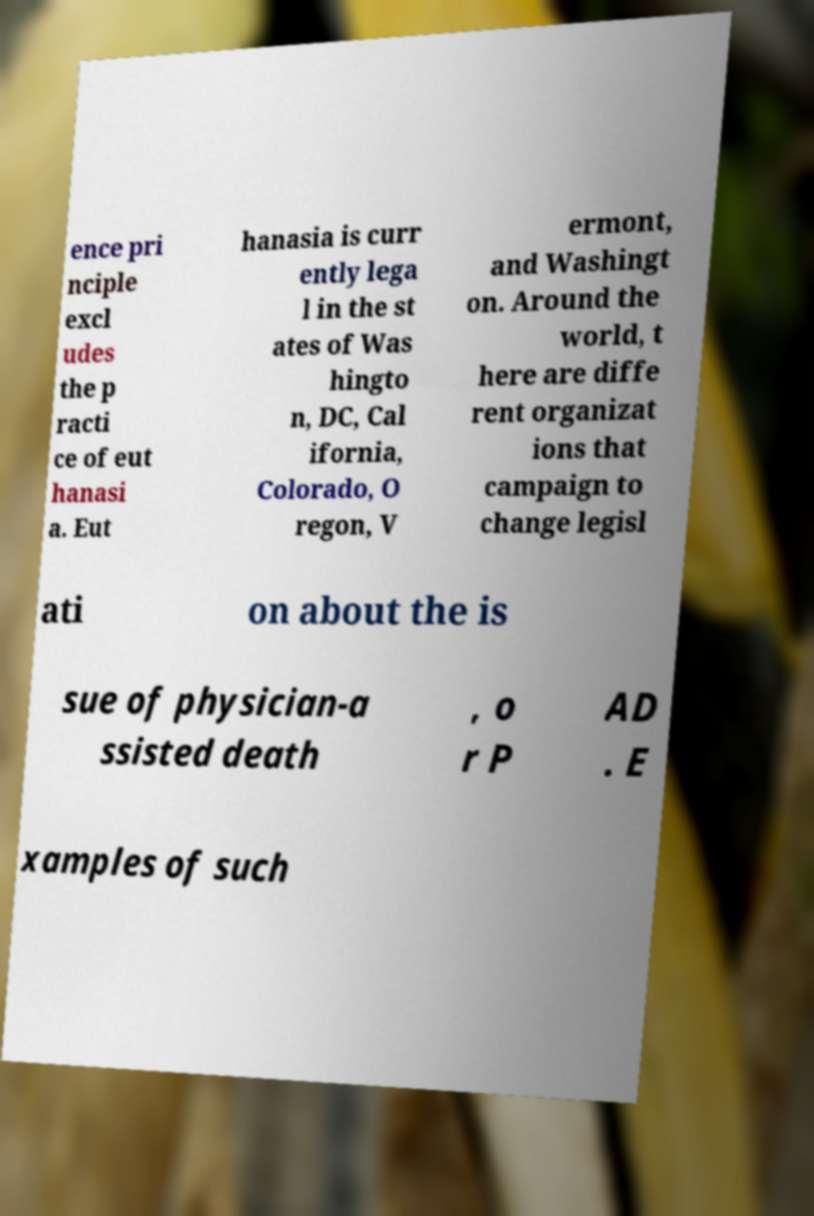I need the written content from this picture converted into text. Can you do that? ence pri nciple excl udes the p racti ce of eut hanasi a. Eut hanasia is curr ently lega l in the st ates of Was hingto n, DC, Cal ifornia, Colorado, O regon, V ermont, and Washingt on. Around the world, t here are diffe rent organizat ions that campaign to change legisl ati on about the is sue of physician-a ssisted death , o r P AD . E xamples of such 